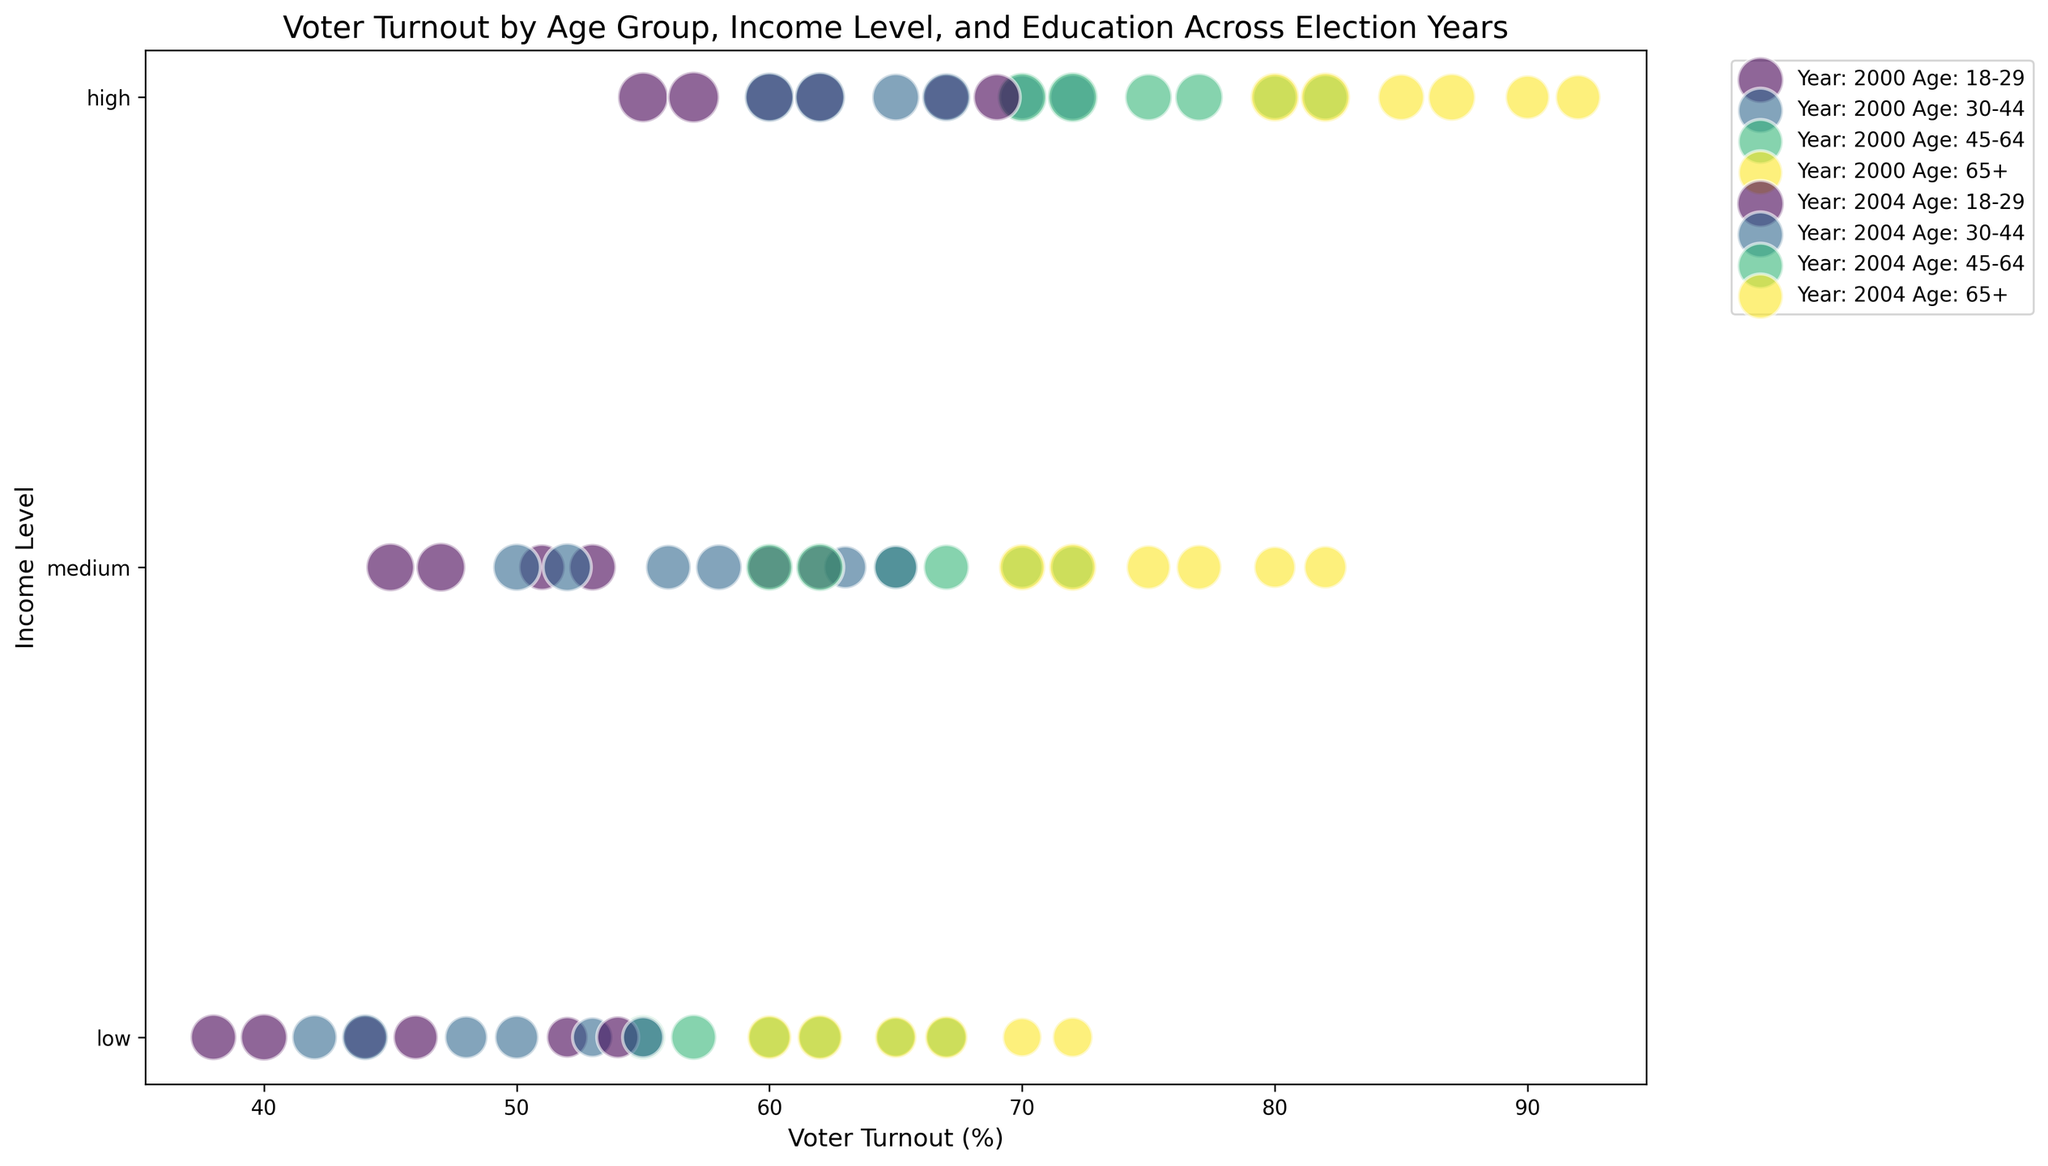What age group and income level had the highest voter turnout in 2004? First, identify the highest voter turnout percentage in the 2004 data. Then, find the corresponding age group and income level. The highest voter turnout in 2004 is 92%, and the corresponding age group is 65+ with a high income level.
Answer: 65+, high Which age group showed the largest increase in voter turnout from 2000 to 2004 among those with medium income levels and some college education? Look at the voter turnout for the medium-income some college education group in 2000 and 2004 for each age group. Calculate the difference and find the largest. For age group 65+, voter turnout increased from 75% in 2000 to 77% in 2004. Similarly, for age group 45-64, it increased from 65% to 67%. For age group 30-44, it increased from 56% to 58%. For age group 18-29, it increased from 51% to 53%. The largest increase is for age group 18-29 with a 2% increase.
Answer: 18-29 What is the total size of the bubble for the high-income group with a college degree or higher in 2000 and 2004 combined? Locate the sizes corresponding to each year for the high-income group with bachelor and above education. For 2000, the size is 470 (45-64) + 460 (65+). For 2004, the size is 520 (18-29) + 500 (30-44) + 580 (65+). Sum these sizes: 460 + 470 + 520 + 500 + 580 = 2530.
Answer: 2530 Which had a higher voter turnout in 2000: 30-44 with medium income and some college or 45-64 with low income and bachelor and above? Compare the voter turnout percentages for the specified groups. For 30-44 with medium income and some college in 2000, it is 56%. For 45-64 with low income and bachelor and above in 2000, it is 65%.
Answer: 45-64 with low income and bachelor and above Which color represents the 18-29 age group in the chart? The color mapping is determined by indexing each unique age group from the color map. Since 18-29 is often the first age group mentioned, it typically corresponds to the first color in the viridis colormap. It's usually a blue or bluish shade.
Answer: Blue 